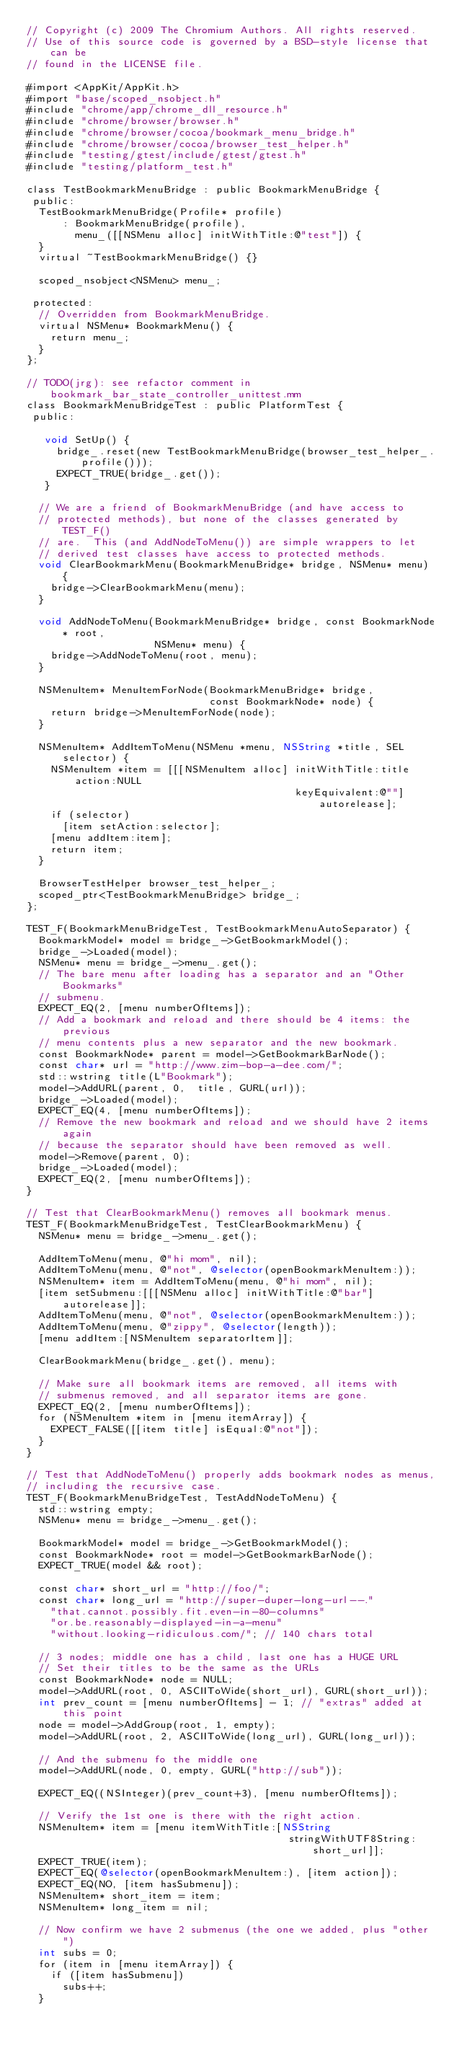Convert code to text. <code><loc_0><loc_0><loc_500><loc_500><_ObjectiveC_>// Copyright (c) 2009 The Chromium Authors. All rights reserved.
// Use of this source code is governed by a BSD-style license that can be
// found in the LICENSE file.

#import <AppKit/AppKit.h>
#import "base/scoped_nsobject.h"
#include "chrome/app/chrome_dll_resource.h"
#include "chrome/browser/browser.h"
#include "chrome/browser/cocoa/bookmark_menu_bridge.h"
#include "chrome/browser/cocoa/browser_test_helper.h"
#include "testing/gtest/include/gtest/gtest.h"
#include "testing/platform_test.h"

class TestBookmarkMenuBridge : public BookmarkMenuBridge {
 public:
  TestBookmarkMenuBridge(Profile* profile)
      : BookmarkMenuBridge(profile),
        menu_([[NSMenu alloc] initWithTitle:@"test"]) {
  }
  virtual ~TestBookmarkMenuBridge() {}

  scoped_nsobject<NSMenu> menu_;

 protected:
  // Overridden from BookmarkMenuBridge.
  virtual NSMenu* BookmarkMenu() {
    return menu_;
  }
};

// TODO(jrg): see refactor comment in bookmark_bar_state_controller_unittest.mm
class BookmarkMenuBridgeTest : public PlatformTest {
 public:

   void SetUp() {
     bridge_.reset(new TestBookmarkMenuBridge(browser_test_helper_.profile()));
     EXPECT_TRUE(bridge_.get());
   }

  // We are a friend of BookmarkMenuBridge (and have access to
  // protected methods), but none of the classes generated by TEST_F()
  // are.  This (and AddNodeToMenu()) are simple wrappers to let
  // derived test classes have access to protected methods.
  void ClearBookmarkMenu(BookmarkMenuBridge* bridge, NSMenu* menu) {
    bridge->ClearBookmarkMenu(menu);
  }

  void AddNodeToMenu(BookmarkMenuBridge* bridge, const BookmarkNode* root,
                     NSMenu* menu) {
    bridge->AddNodeToMenu(root, menu);
  }

  NSMenuItem* MenuItemForNode(BookmarkMenuBridge* bridge,
                              const BookmarkNode* node) {
    return bridge->MenuItemForNode(node);
  }

  NSMenuItem* AddItemToMenu(NSMenu *menu, NSString *title, SEL selector) {
    NSMenuItem *item = [[[NSMenuItem alloc] initWithTitle:title action:NULL
                                            keyEquivalent:@""] autorelease];
    if (selector)
      [item setAction:selector];
    [menu addItem:item];
    return item;
  }

  BrowserTestHelper browser_test_helper_;
  scoped_ptr<TestBookmarkMenuBridge> bridge_;
};

TEST_F(BookmarkMenuBridgeTest, TestBookmarkMenuAutoSeparator) {
  BookmarkModel* model = bridge_->GetBookmarkModel();
  bridge_->Loaded(model);
  NSMenu* menu = bridge_->menu_.get();
  // The bare menu after loading has a separator and an "Other Bookmarks"
  // submenu.
  EXPECT_EQ(2, [menu numberOfItems]);
  // Add a bookmark and reload and there should be 4 items: the previous
  // menu contents plus a new separator and the new bookmark.
  const BookmarkNode* parent = model->GetBookmarkBarNode();
  const char* url = "http://www.zim-bop-a-dee.com/";
  std::wstring title(L"Bookmark");
  model->AddURL(parent, 0,  title, GURL(url));
  bridge_->Loaded(model);
  EXPECT_EQ(4, [menu numberOfItems]);
  // Remove the new bookmark and reload and we should have 2 items again
  // because the separator should have been removed as well.
  model->Remove(parent, 0);
  bridge_->Loaded(model);
  EXPECT_EQ(2, [menu numberOfItems]);
}

// Test that ClearBookmarkMenu() removes all bookmark menus.
TEST_F(BookmarkMenuBridgeTest, TestClearBookmarkMenu) {
  NSMenu* menu = bridge_->menu_.get();

  AddItemToMenu(menu, @"hi mom", nil);
  AddItemToMenu(menu, @"not", @selector(openBookmarkMenuItem:));
  NSMenuItem* item = AddItemToMenu(menu, @"hi mom", nil);
  [item setSubmenu:[[[NSMenu alloc] initWithTitle:@"bar"] autorelease]];
  AddItemToMenu(menu, @"not", @selector(openBookmarkMenuItem:));
  AddItemToMenu(menu, @"zippy", @selector(length));
  [menu addItem:[NSMenuItem separatorItem]];

  ClearBookmarkMenu(bridge_.get(), menu);

  // Make sure all bookmark items are removed, all items with
  // submenus removed, and all separator items are gone.
  EXPECT_EQ(2, [menu numberOfItems]);
  for (NSMenuItem *item in [menu itemArray]) {
    EXPECT_FALSE([[item title] isEqual:@"not"]);
  }
}

// Test that AddNodeToMenu() properly adds bookmark nodes as menus,
// including the recursive case.
TEST_F(BookmarkMenuBridgeTest, TestAddNodeToMenu) {
  std::wstring empty;
  NSMenu* menu = bridge_->menu_.get();

  BookmarkModel* model = bridge_->GetBookmarkModel();
  const BookmarkNode* root = model->GetBookmarkBarNode();
  EXPECT_TRUE(model && root);

  const char* short_url = "http://foo/";
  const char* long_url = "http://super-duper-long-url--."
    "that.cannot.possibly.fit.even-in-80-columns"
    "or.be.reasonably-displayed-in-a-menu"
    "without.looking-ridiculous.com/"; // 140 chars total

  // 3 nodes; middle one has a child, last one has a HUGE URL
  // Set their titles to be the same as the URLs
  const BookmarkNode* node = NULL;
  model->AddURL(root, 0, ASCIIToWide(short_url), GURL(short_url));
  int prev_count = [menu numberOfItems] - 1; // "extras" added at this point
  node = model->AddGroup(root, 1, empty);
  model->AddURL(root, 2, ASCIIToWide(long_url), GURL(long_url));

  // And the submenu fo the middle one
  model->AddURL(node, 0, empty, GURL("http://sub"));

  EXPECT_EQ((NSInteger)(prev_count+3), [menu numberOfItems]);

  // Verify the 1st one is there with the right action.
  NSMenuItem* item = [menu itemWithTitle:[NSString
                                           stringWithUTF8String:short_url]];
  EXPECT_TRUE(item);
  EXPECT_EQ(@selector(openBookmarkMenuItem:), [item action]);
  EXPECT_EQ(NO, [item hasSubmenu]);
  NSMenuItem* short_item = item;
  NSMenuItem* long_item = nil;

  // Now confirm we have 2 submenus (the one we added, plus "other")
  int subs = 0;
  for (item in [menu itemArray]) {
    if ([item hasSubmenu])
      subs++;
  }</code> 